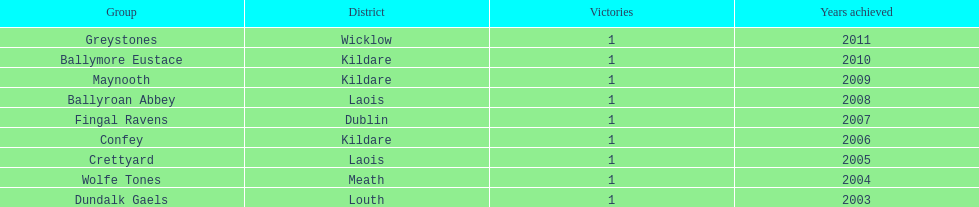What is the years won for each team 2011, 2010, 2009, 2008, 2007, 2006, 2005, 2004, 2003. 